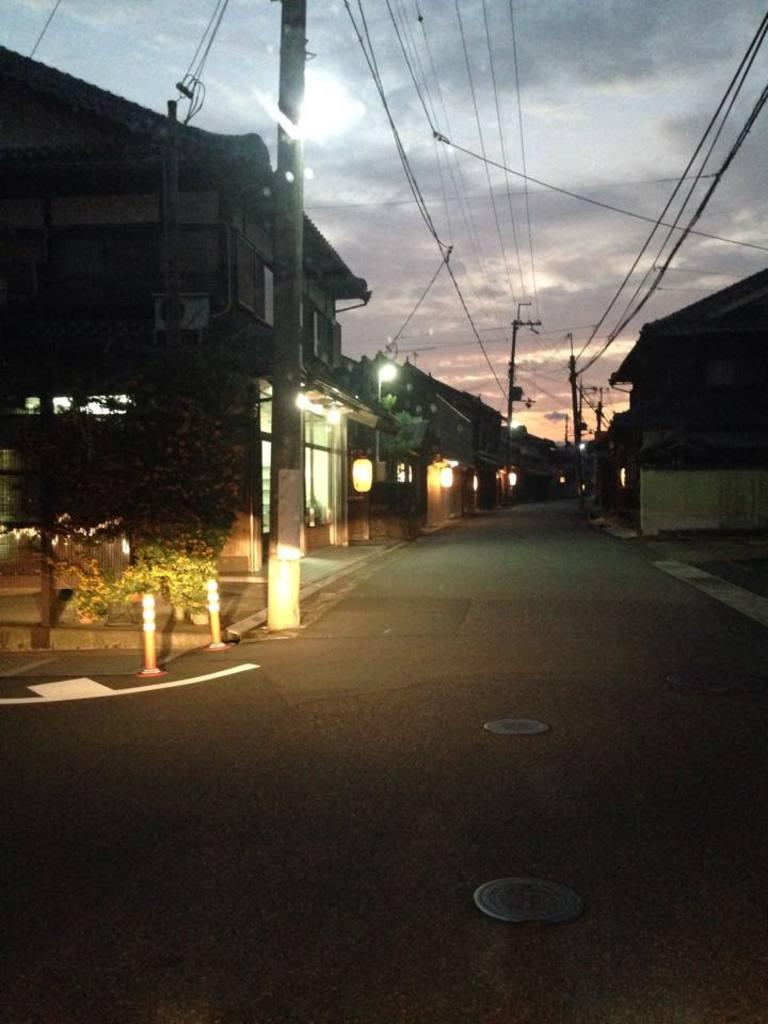What type of structures can be seen in the image? There are houses in the image. What else is visible in the image besides the houses? There are lights, current polls, plants, and a pole visible in the image. What is the condition of the sky in the image? The sky is visible at the top of the image. What type of anger can be seen on the faces of the people in the image? There are no people present in the image, so it is not possible to determine their emotions or expressions. Can you tell me how many balloons are tied to the pole in the image? There are no balloons present in the image; only a pole is visible. 